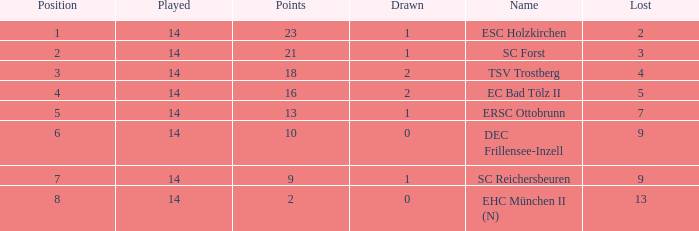Which Lost is the lowest one that has a Name of esc holzkirchen, and Played smaller than 14? None. 